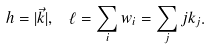Convert formula to latex. <formula><loc_0><loc_0><loc_500><loc_500>h = | \vec { k } | , \, \ \ell = \sum _ { i } w _ { i } = \sum _ { j } j k _ { j } .</formula> 